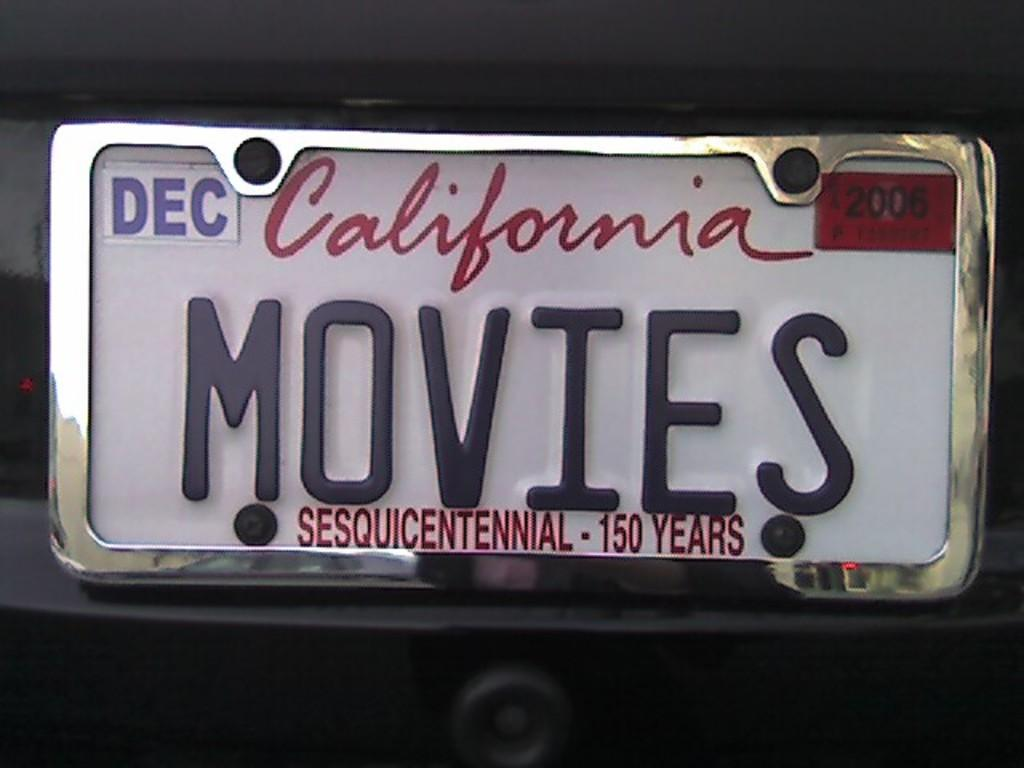<image>
Give a short and clear explanation of the subsequent image. A California licence says MOVIES and was registered in December. 